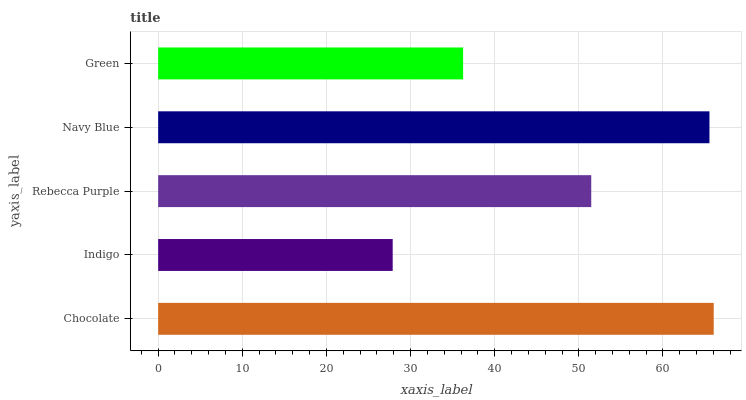Is Indigo the minimum?
Answer yes or no. Yes. Is Chocolate the maximum?
Answer yes or no. Yes. Is Rebecca Purple the minimum?
Answer yes or no. No. Is Rebecca Purple the maximum?
Answer yes or no. No. Is Rebecca Purple greater than Indigo?
Answer yes or no. Yes. Is Indigo less than Rebecca Purple?
Answer yes or no. Yes. Is Indigo greater than Rebecca Purple?
Answer yes or no. No. Is Rebecca Purple less than Indigo?
Answer yes or no. No. Is Rebecca Purple the high median?
Answer yes or no. Yes. Is Rebecca Purple the low median?
Answer yes or no. Yes. Is Indigo the high median?
Answer yes or no. No. Is Chocolate the low median?
Answer yes or no. No. 